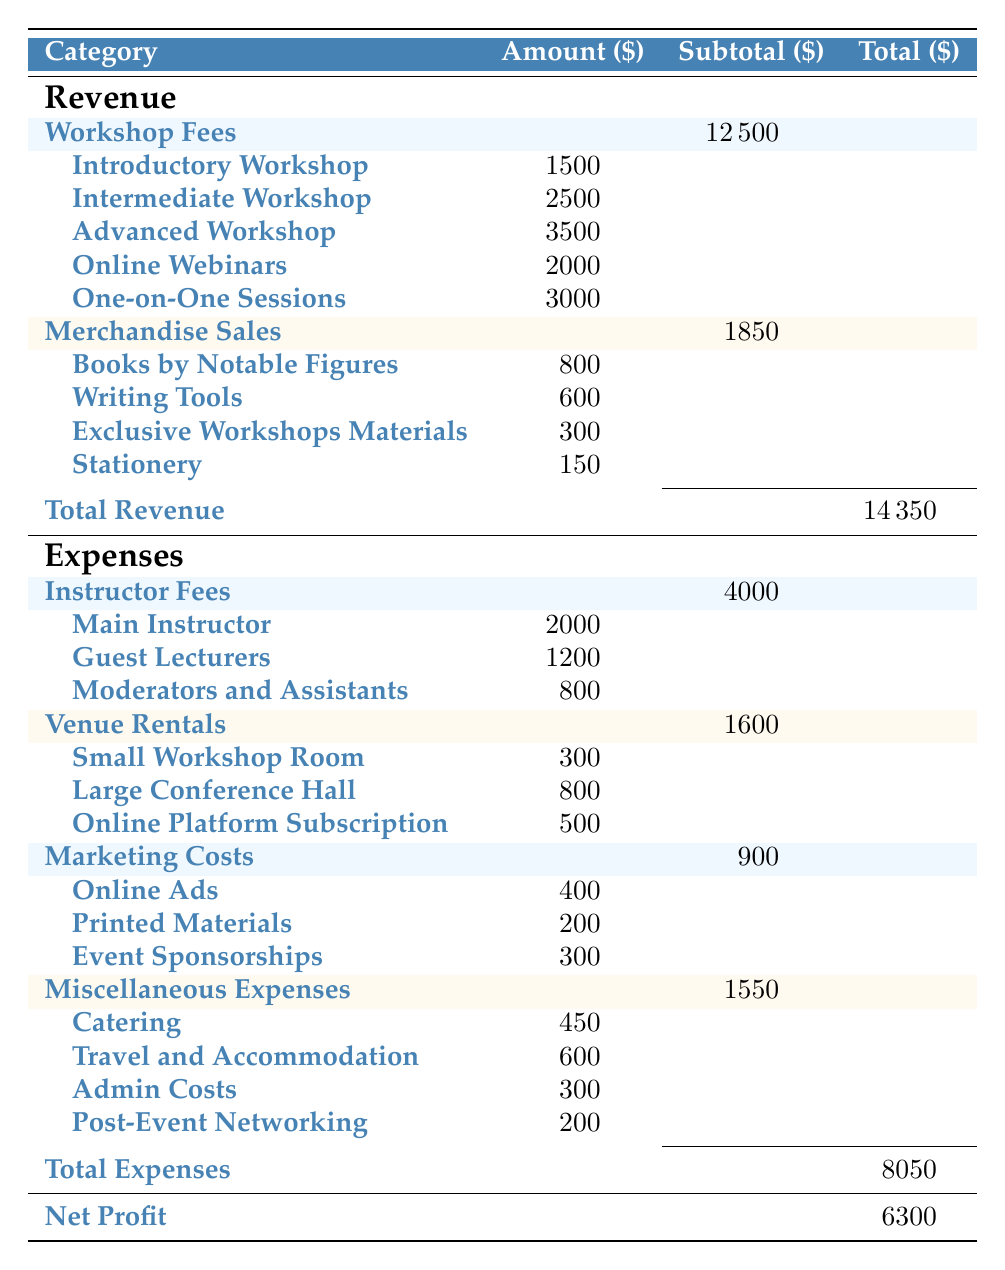What is the total revenue generated from workshop fees? The total revenue from workshop fees is provided in the table under the "Revenue" section. The subtotal for workshop fees is shown as 12500.
Answer: 12500 What is the total amount spent on miscellaneous expenses? The total for miscellaneous expenses is listed in the table under the "Expenses" section, which shows a subtotal of 1550 for that category.
Answer: 1550 Did the total revenue exceed the total expenses? The total revenue is 14450, while the total expenses are 8050. Since 14450 is greater than 8050, the statement is true.
Answer: Yes What is the net profit generated by the writing workshops? The net profit is calculated in the table under the "Net Profit" row, showing a final value of 6300.
Answer: 6300 What is the total income from merchandise sales? The total for merchandise sales is provided in the table as a subtotal of 1850. This represents the total income from all merchandise sold during the workshops.
Answer: 1850 How much more was collected from one-on-one sessions than from the introductory workshop? One-on-one sessions generated 3000, while the introductory workshop earned 1500. The difference is calculated as 3000 - 1500 = 1500.
Answer: 1500 What is the total spent on instructor fees and venue rentals combined? Studio Rentals total 1600 and Instructor Fees total 4000. To find the combined total, we sum these: 4000 + 1600 = 5600.
Answer: 5600 Are the expenses for online platform subscriptions higher than for printed materials? The expense for online platform subscriptions is 500 and for printed materials is 200. Since 500 is greater than 200, the statement is true.
Answer: Yes What percentage of total revenue comes from one-on-one sessions? One-on-one sessions earned 3000 out of the total revenue of 14450. To find the percentage, we use the formula (3000 / 14450) * 100 = 20.78%.
Answer: 20.78% 